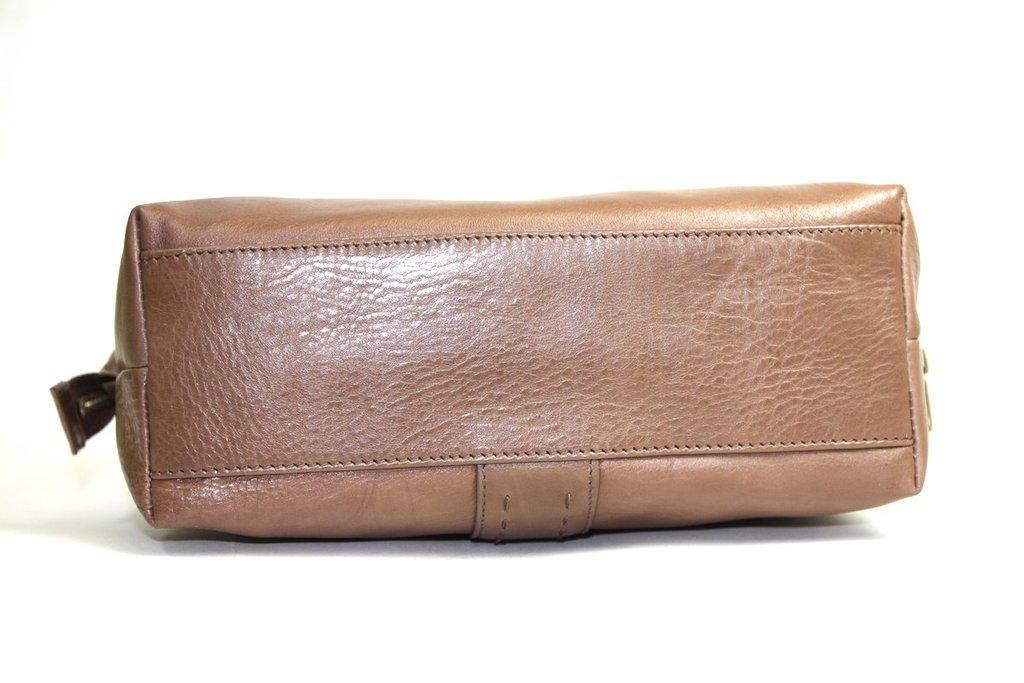Please provide a concise description of this image. In this image, there is a bag which is colored brown. 